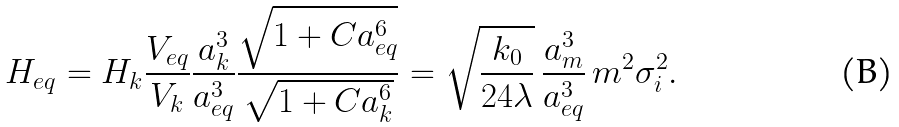Convert formula to latex. <formula><loc_0><loc_0><loc_500><loc_500>H _ { e q } = H _ { k } \frac { V _ { e q } } { V _ { k } } \frac { a _ { k } ^ { 3 } } { a _ { e q } ^ { 3 } } \frac { \sqrt { 1 + C a _ { e q } ^ { 6 } } } { \sqrt { 1 + C a _ { k } ^ { 6 } } } = \sqrt { \frac { k _ { 0 } } { 2 4 \lambda } } \, \frac { a _ { m } ^ { 3 } } { a _ { e q } ^ { 3 } } \, m ^ { 2 } \sigma _ { i } ^ { 2 } .</formula> 